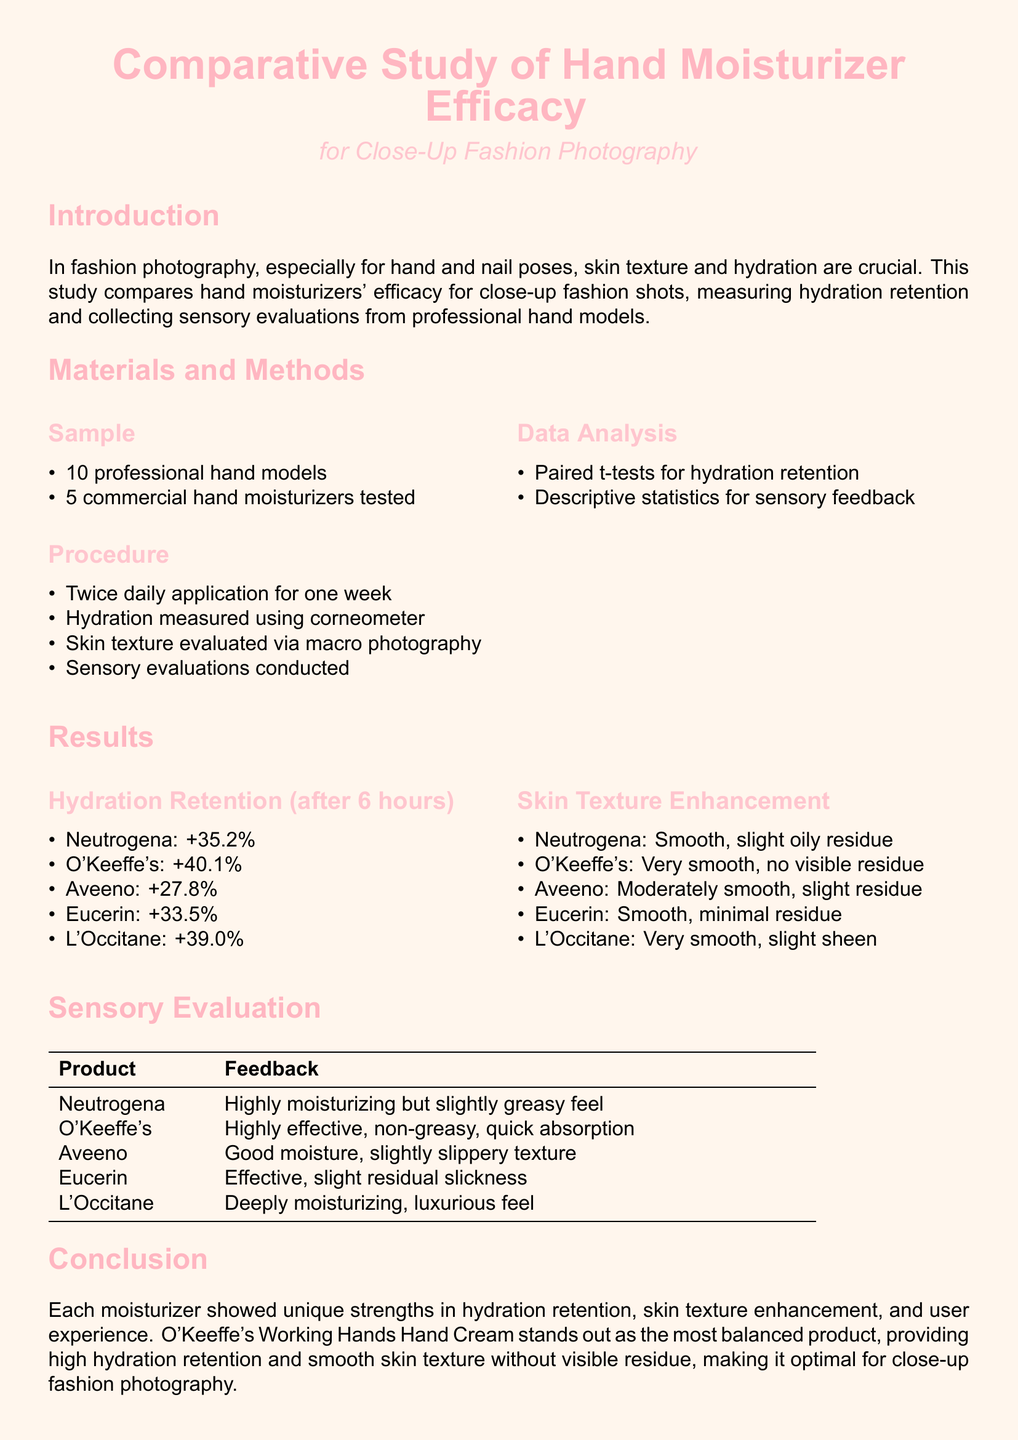What is the main focus of the study? The main focus of the study is on hand moisturizers' efficacy for close-up fashion shots, specifically skin texture and hydration.
Answer: skin texture enhancement How many hand models participated in the study? The number of hand models participating in the study is mentioned in the sample section.
Answer: 10 What was the hydration retention percentage increase for O'Keeffe's? O'Keeffe's hydration retention percentage is shown in the results' hydration retention section.
Answer: 40.1 Which hand moisturizer was noted for having a very smooth texture and no visible residue? The document lists the skin texture evaluations for each moisturizer, highlighting O'Keeffe's result.
Answer: O'Keeffe's What statistical method was used to analyze hydration retention? The analysis section indicates the statistical method used, which involves a paired test.
Answer: Paired t-tests Which moisturizer received feedback for being "deeply moisturizing"? The sensory evaluation table provides feedback for each moisturizer, mentioning L'Occitane.
Answer: L'Occitane What was the overall conclusion about O'Keeffe's? The conclusion summarizes O'Keeffe's performance compared to others, focusing on hydration and texture.
Answer: most balanced product What measurement tool was utilized to measure hydration? The hydration measurement tool is specified in the materials methodology.
Answer: corneometer What type of evaluations were collected apart from hydration measurements? The methodology mentions another type of evaluation conducted during the study.
Answer: sensory evaluations 